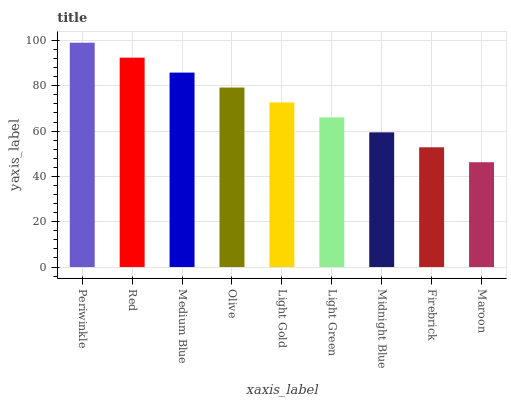Is Maroon the minimum?
Answer yes or no. Yes. Is Periwinkle the maximum?
Answer yes or no. Yes. Is Red the minimum?
Answer yes or no. No. Is Red the maximum?
Answer yes or no. No. Is Periwinkle greater than Red?
Answer yes or no. Yes. Is Red less than Periwinkle?
Answer yes or no. Yes. Is Red greater than Periwinkle?
Answer yes or no. No. Is Periwinkle less than Red?
Answer yes or no. No. Is Light Gold the high median?
Answer yes or no. Yes. Is Light Gold the low median?
Answer yes or no. Yes. Is Olive the high median?
Answer yes or no. No. Is Periwinkle the low median?
Answer yes or no. No. 